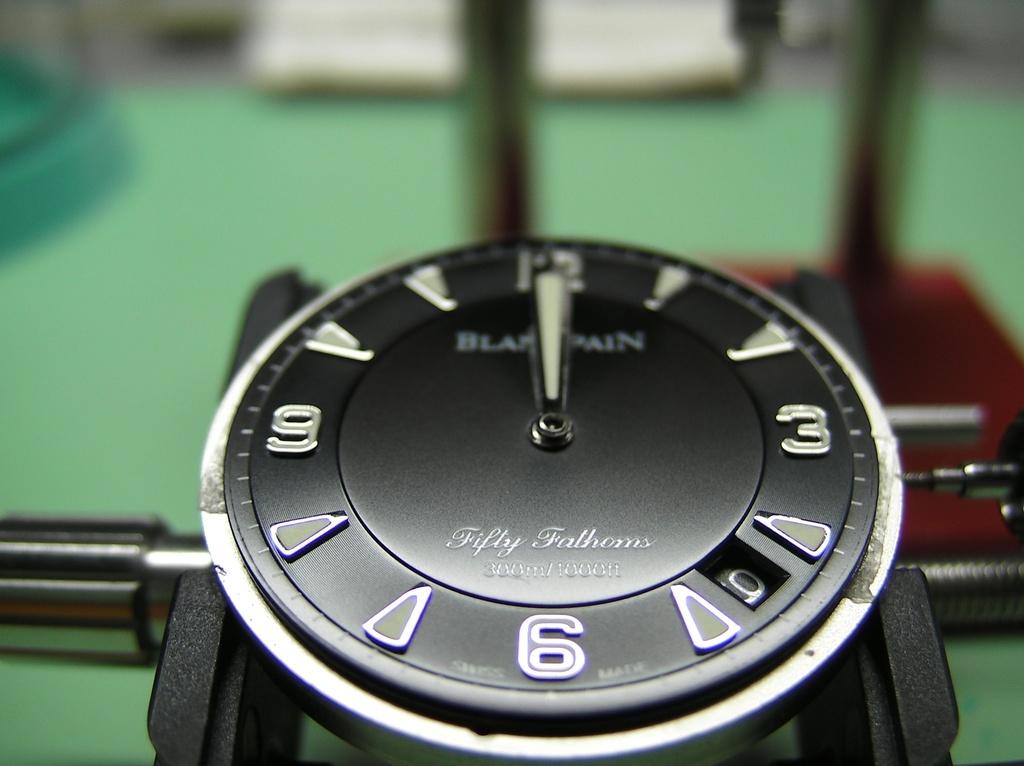How many fathoms are there for this watch?
Give a very brief answer. Fifty. What number is the clock hand on?
Offer a very short reply. 12. 